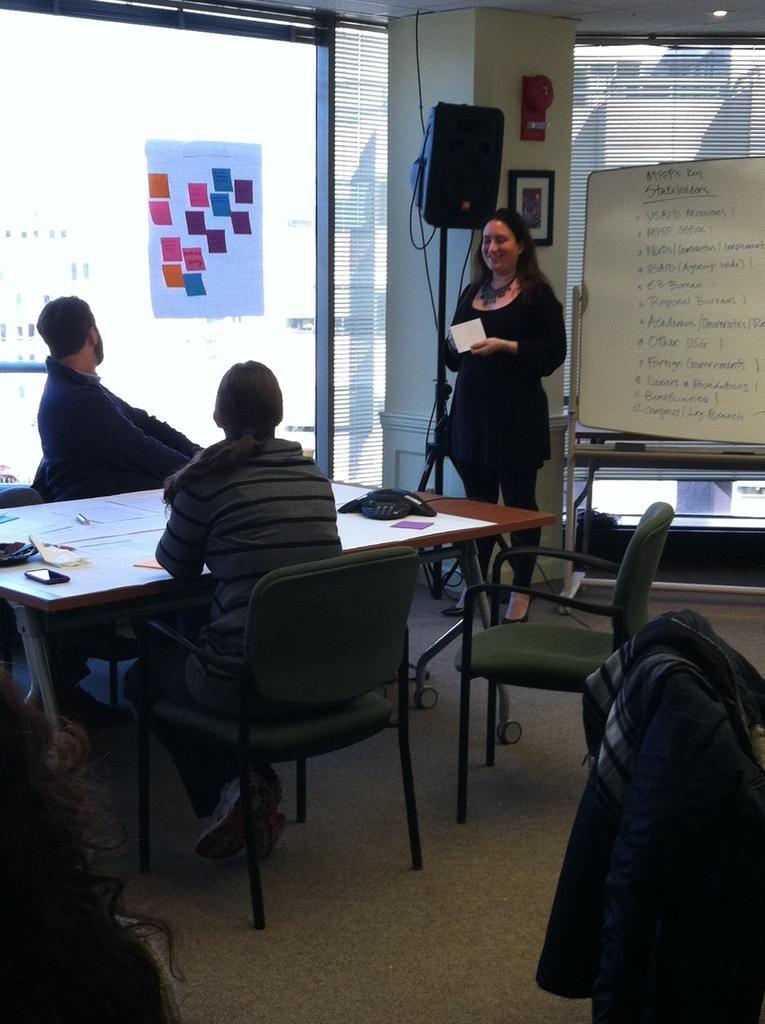In one or two sentences, can you explain what this image depicts? There is a woman sitting on a chair. There is another woman who is standing at the right side and she is smiling. There is a man on the left side. This is a table. This is a telephone and this is a mobile. 